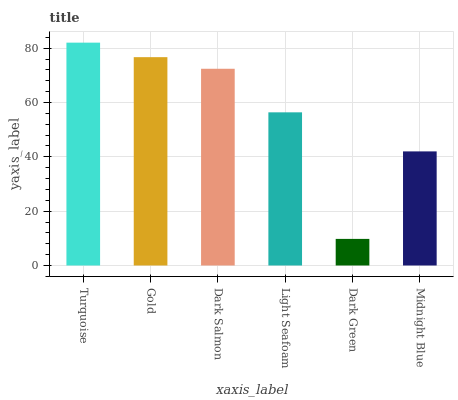Is Dark Green the minimum?
Answer yes or no. Yes. Is Turquoise the maximum?
Answer yes or no. Yes. Is Gold the minimum?
Answer yes or no. No. Is Gold the maximum?
Answer yes or no. No. Is Turquoise greater than Gold?
Answer yes or no. Yes. Is Gold less than Turquoise?
Answer yes or no. Yes. Is Gold greater than Turquoise?
Answer yes or no. No. Is Turquoise less than Gold?
Answer yes or no. No. Is Dark Salmon the high median?
Answer yes or no. Yes. Is Light Seafoam the low median?
Answer yes or no. Yes. Is Dark Green the high median?
Answer yes or no. No. Is Midnight Blue the low median?
Answer yes or no. No. 